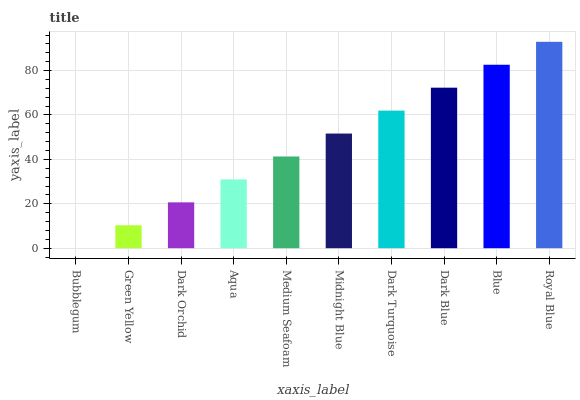Is Bubblegum the minimum?
Answer yes or no. Yes. Is Royal Blue the maximum?
Answer yes or no. Yes. Is Green Yellow the minimum?
Answer yes or no. No. Is Green Yellow the maximum?
Answer yes or no. No. Is Green Yellow greater than Bubblegum?
Answer yes or no. Yes. Is Bubblegum less than Green Yellow?
Answer yes or no. Yes. Is Bubblegum greater than Green Yellow?
Answer yes or no. No. Is Green Yellow less than Bubblegum?
Answer yes or no. No. Is Midnight Blue the high median?
Answer yes or no. Yes. Is Medium Seafoam the low median?
Answer yes or no. Yes. Is Dark Orchid the high median?
Answer yes or no. No. Is Aqua the low median?
Answer yes or no. No. 